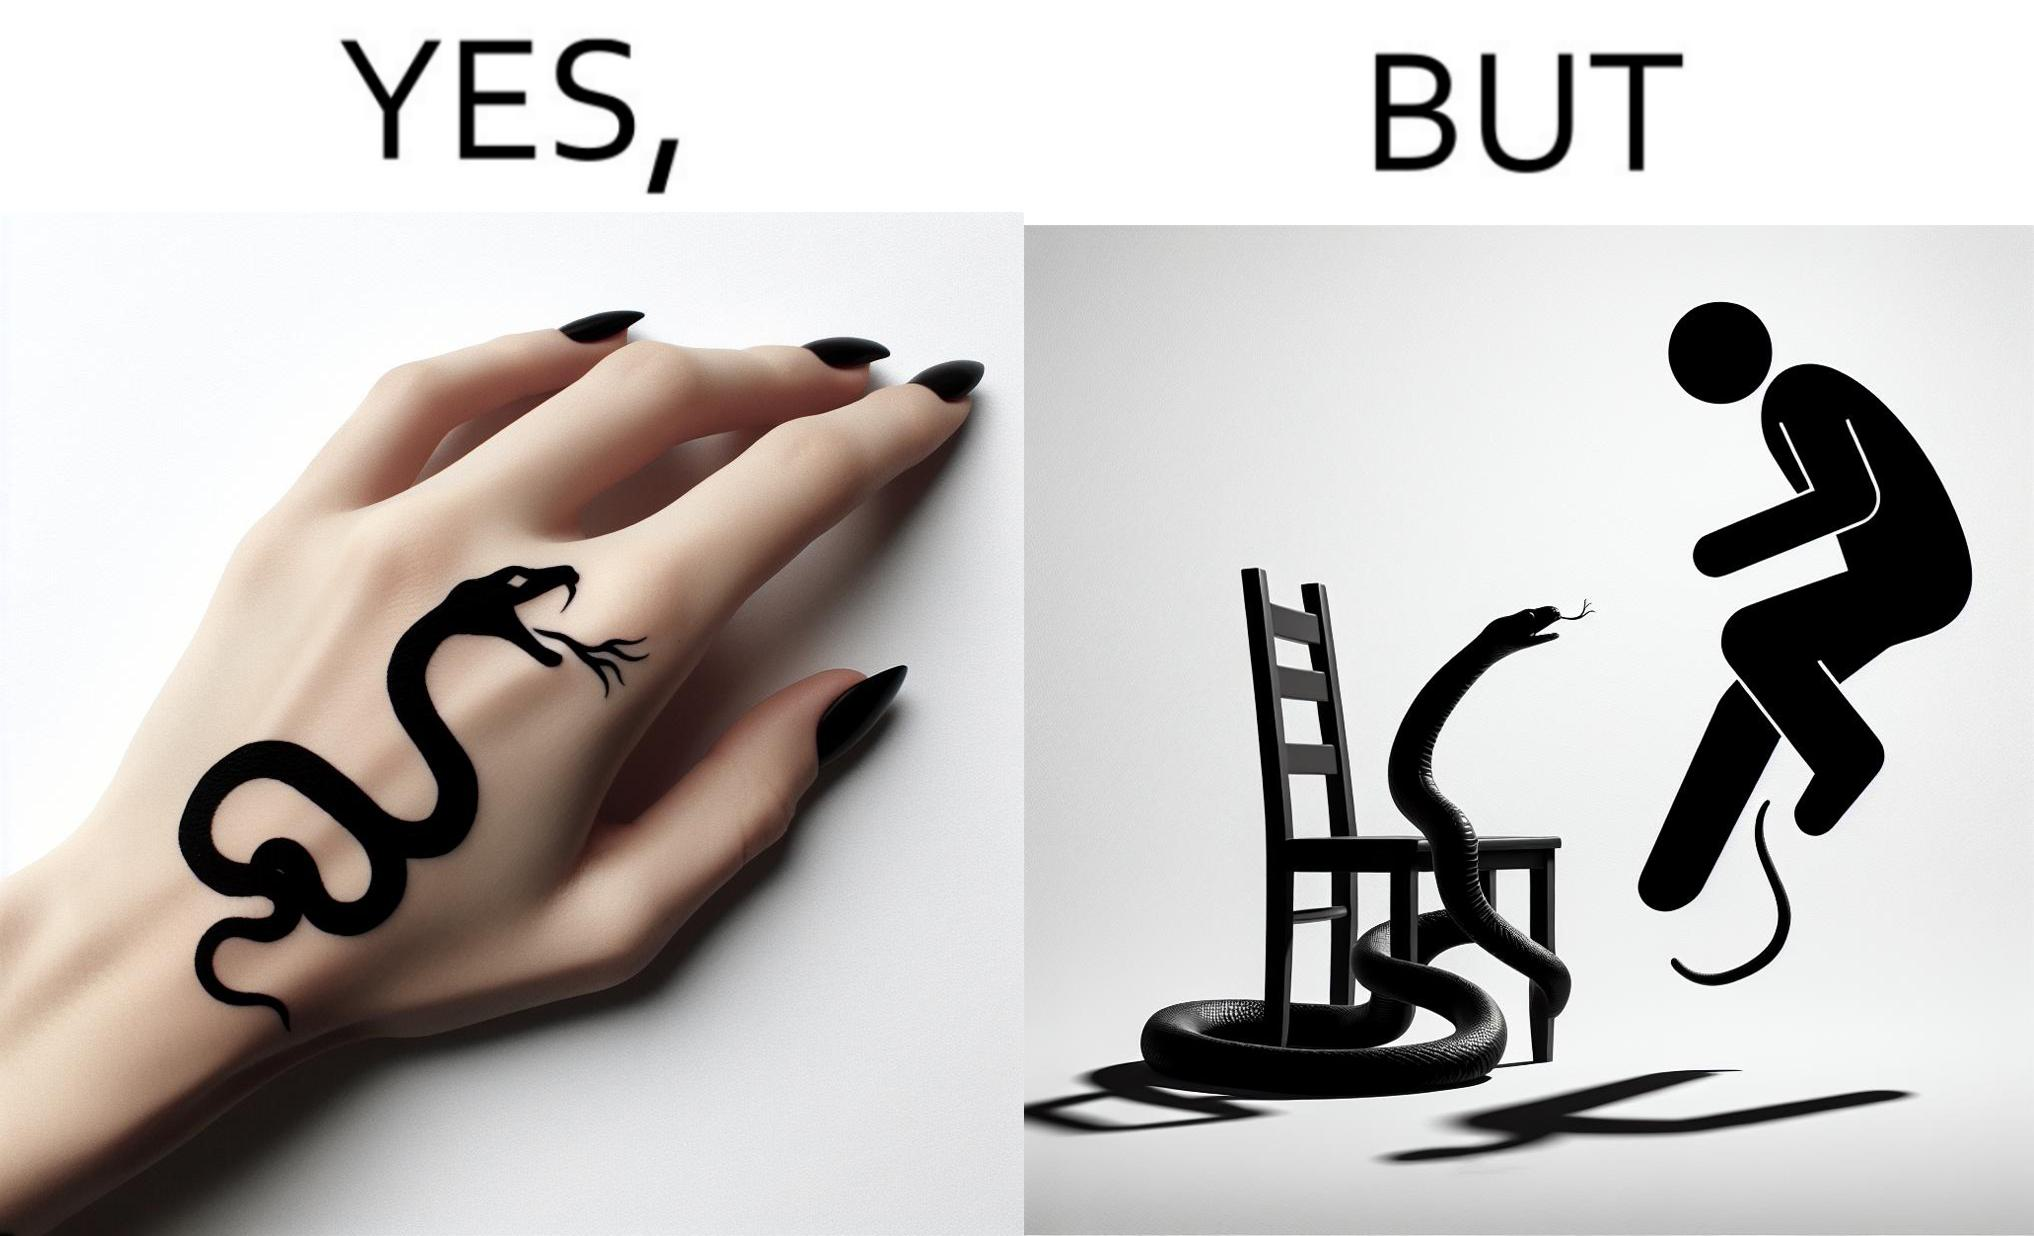Is this a satirical image? Yes, this image is satirical. 